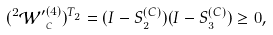Convert formula to latex. <formula><loc_0><loc_0><loc_500><loc_500>( ^ { 2 } \mathcal { W ^ { \prime } } _ { _ { C } } ^ { ( 4 ) } ) ^ { T _ { _ { 2 } } } = ( I - S _ { _ { 2 } } ^ { ( C ) } ) ( I - S _ { _ { 3 } } ^ { ( C ) } ) \geq 0 ,</formula> 